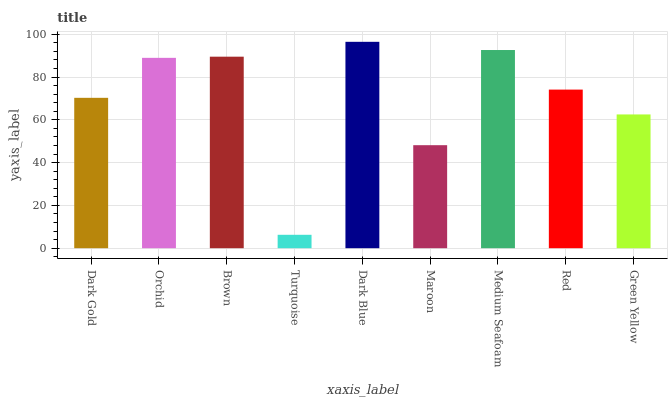Is Orchid the minimum?
Answer yes or no. No. Is Orchid the maximum?
Answer yes or no. No. Is Orchid greater than Dark Gold?
Answer yes or no. Yes. Is Dark Gold less than Orchid?
Answer yes or no. Yes. Is Dark Gold greater than Orchid?
Answer yes or no. No. Is Orchid less than Dark Gold?
Answer yes or no. No. Is Red the high median?
Answer yes or no. Yes. Is Red the low median?
Answer yes or no. Yes. Is Dark Blue the high median?
Answer yes or no. No. Is Dark Gold the low median?
Answer yes or no. No. 